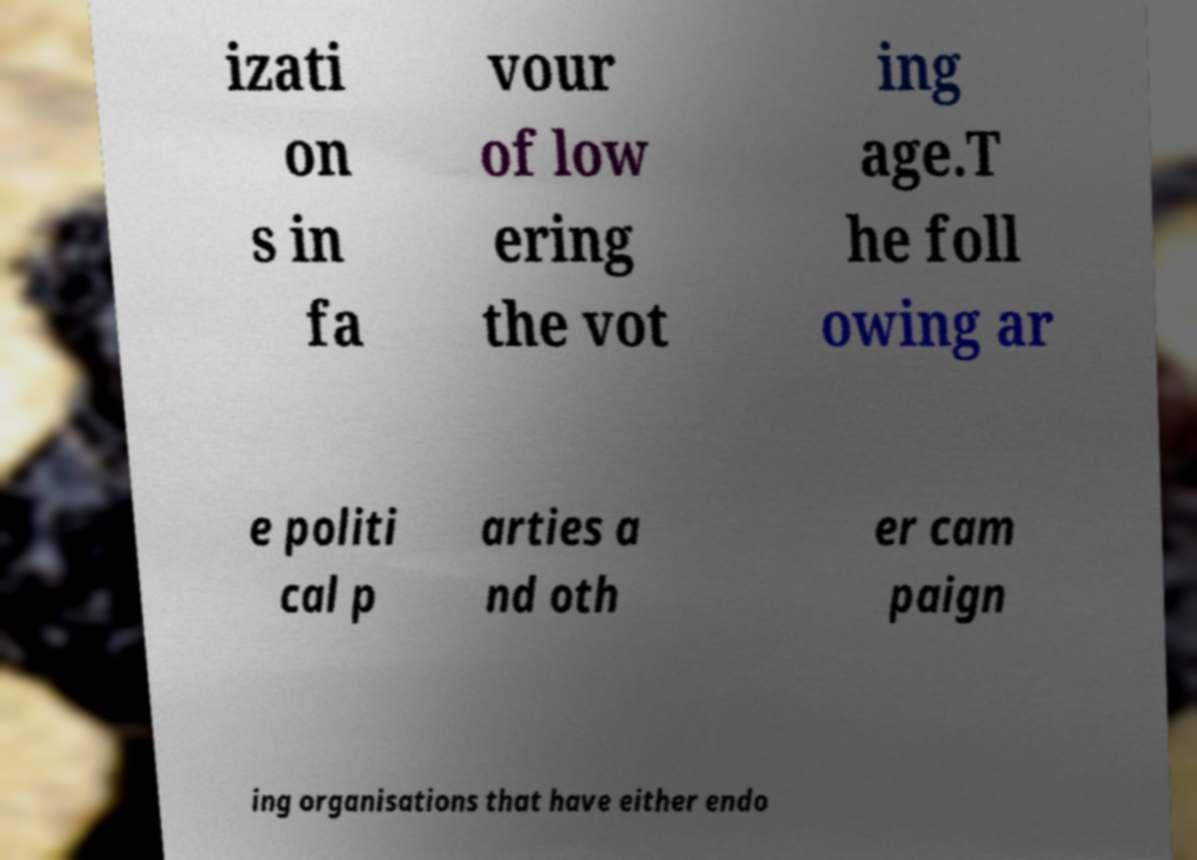Please read and relay the text visible in this image. What does it say? izati on s in fa vour of low ering the vot ing age.T he foll owing ar e politi cal p arties a nd oth er cam paign ing organisations that have either endo 